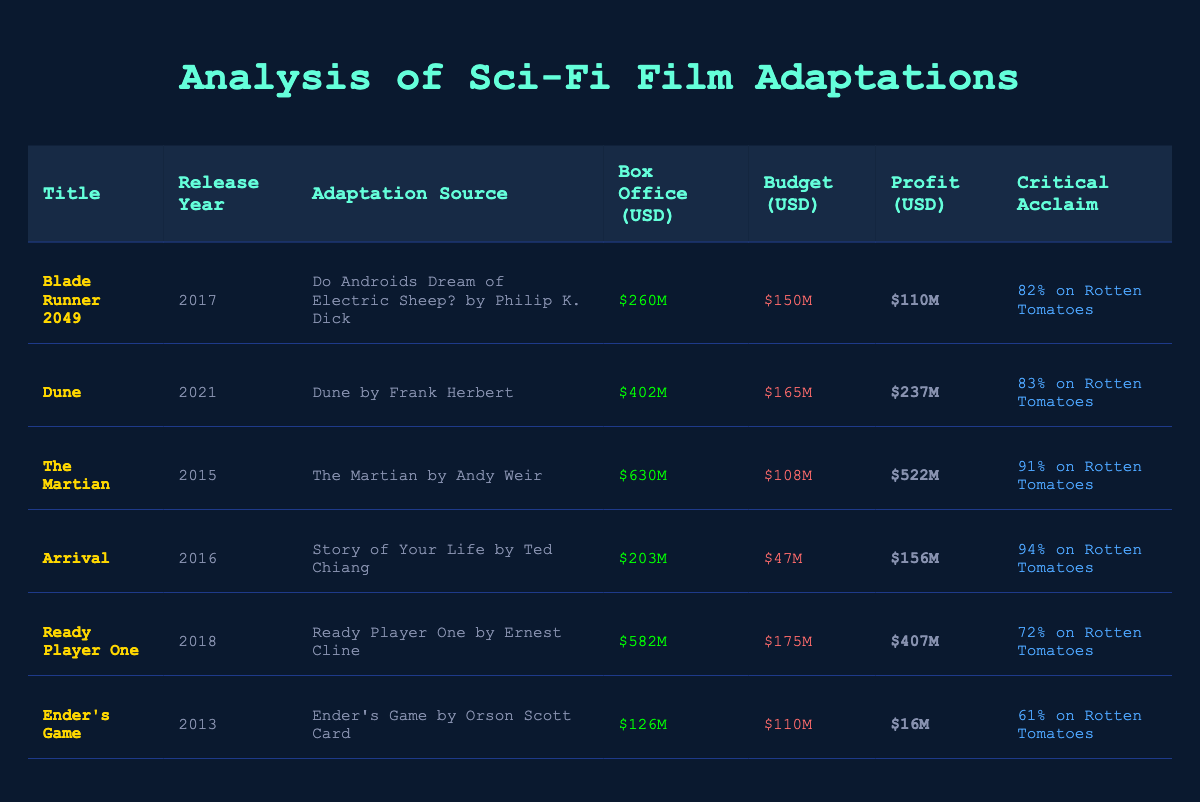What is the box office revenue for "The Martian"? The table states that the box office revenue for "The Martian" is $630 million USD as listed under the "Box Office" column for that title.
Answer: $630 million USD Which film had the highest budget and what was that budget? Looking at the "Budget" column for each film, "Ready Player One" has the highest budget listed at $175 million USD.
Answer: $175 million USD What is the total box office revenue of the films released after 2015? The films released after 2015 are "Blade Runner 2049" ($260M), "Dune" ($402M), "Ready Player One" ($582M), and "Ender's Game" ($126M). The total is 260 + 402 + 582 + 126 = 1370 million USD.
Answer: $1370 million USD Is "Arrival" more critically acclaimed than "Ender's Game"? Checking the "Critical Acclaim" ratings in the table, "Arrival" has 94% on Rotten Tomatoes and "Ender's Game" has 61%. Therefore, "Arrival" is indeed more critically acclaimed.
Answer: Yes What is the profit for "Dune"? To calculate the profit, we subtract the budget from the box office revenue for "Dune": 402 million USD (box office) - 165 million USD (budget) = 237 million USD.
Answer: $237 million USD Which film adaptation has the lowest box office performance and what was its revenue? The film with the lowest box office revenue is "Ender's Game" with $126 million USD noted in the "Box Office" column.
Answer: $126 million USD If we consider only films with critical acclaim above 80%, what is the average box office revenue of those movies? The films with critical acclaim over 80% are "Blade Runner 2049" ($260M), "Dune" ($402M), "The Martian" ($630M), and "Arrival" ($203M). Calculating the total: 260 + 402 + 630 + 203 = 1495 million USD, and there are 4 films, so the average is 1495 / 4 = 373.75 million USD.
Answer: $373.75 million USD Which film has a box office margin (profit) greater than $200 million and what is the name of that film? The profit (box office - budget) for each film needs to be calculated to find the margin greater than $200 million. Only "The Martian" ($522M) and "Ready Player One" ($407M) exceed this value. So both films qualify.
Answer: "The Martian" and "Ready Player One" 